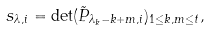<formula> <loc_0><loc_0><loc_500><loc_500>s _ { \lambda , i } = \det ( \tilde { P } _ { \lambda _ { k } - k + m , i } ) _ { 1 \leq k , m \leq t } ,</formula> 